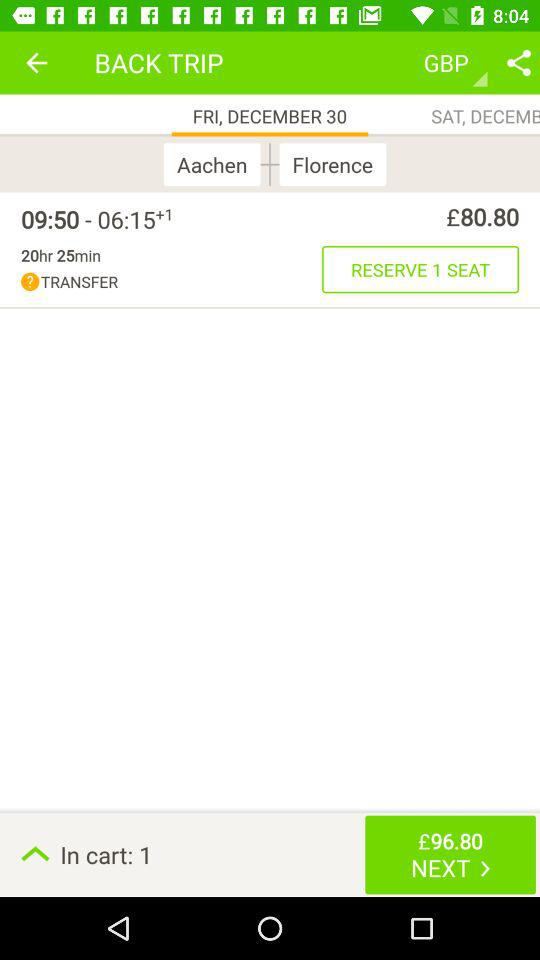From which city to which city will the trip be? The trip will be from Aachen to Florence. 